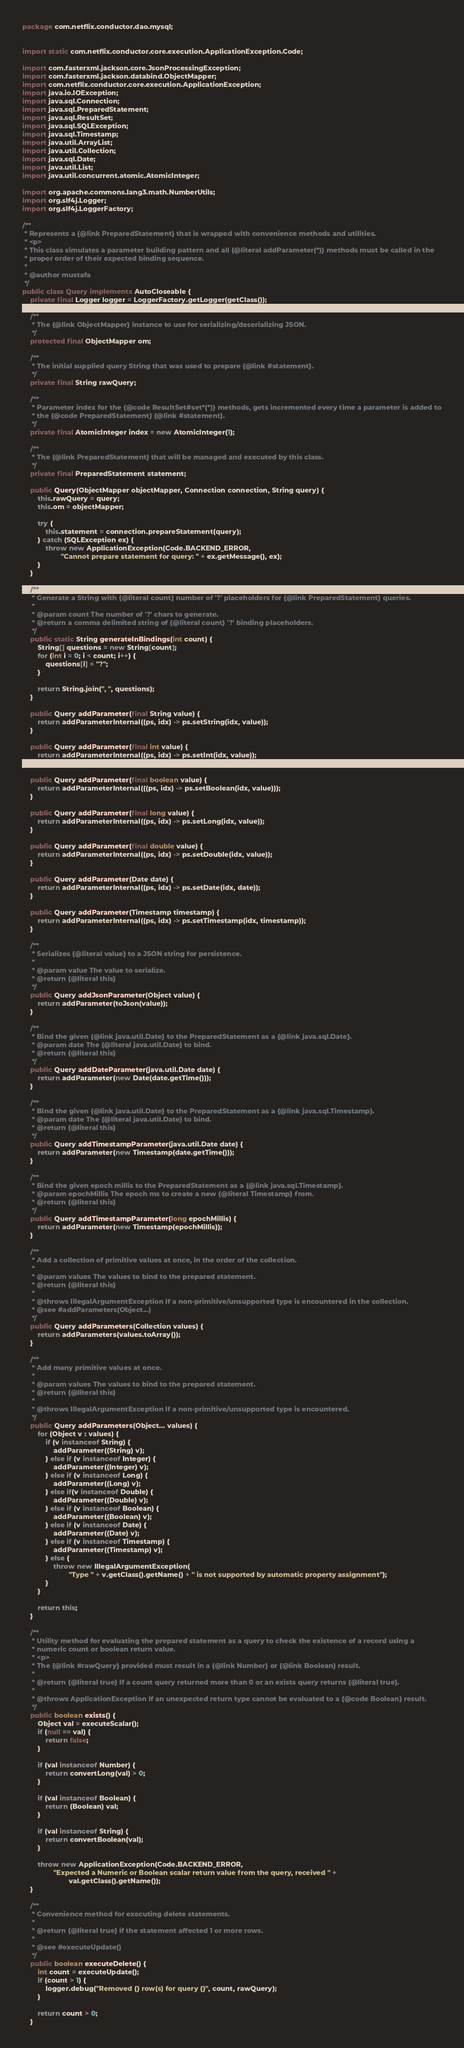<code> <loc_0><loc_0><loc_500><loc_500><_Java_>package com.netflix.conductor.dao.mysql;


import static com.netflix.conductor.core.execution.ApplicationException.Code;

import com.fasterxml.jackson.core.JsonProcessingException;
import com.fasterxml.jackson.databind.ObjectMapper;
import com.netflix.conductor.core.execution.ApplicationException;
import java.io.IOException;
import java.sql.Connection;
import java.sql.PreparedStatement;
import java.sql.ResultSet;
import java.sql.SQLException;
import java.sql.Timestamp;
import java.util.ArrayList;
import java.util.Collection;
import java.sql.Date;
import java.util.List;
import java.util.concurrent.atomic.AtomicInteger;

import org.apache.commons.lang3.math.NumberUtils;
import org.slf4j.Logger;
import org.slf4j.LoggerFactory;

/**
 * Represents a {@link PreparedStatement} that is wrapped with convenience methods and utilities.
 * <p>
 * This class simulates a parameter building pattern and all {@literal addParameter(*)} methods must be called in the
 * proper order of their expected binding sequence.
 *
 * @author mustafa
 */
public class Query implements AutoCloseable {
    private final Logger logger = LoggerFactory.getLogger(getClass());

    /**
     * The {@link ObjectMapper} instance to use for serializing/deserializing JSON.
     */
    protected final ObjectMapper om;

    /**
     * The initial supplied query String that was used to prepare {@link #statement}.
     */
    private final String rawQuery;

    /**
     * Parameter index for the {@code ResultSet#set*(*)} methods, gets incremented every time a parameter is added to
     * the {@code PreparedStatement} {@link #statement}.
     */
    private final AtomicInteger index = new AtomicInteger(1);

    /**
     * The {@link PreparedStatement} that will be managed and executed by this class.
     */
    private final PreparedStatement statement;

    public Query(ObjectMapper objectMapper, Connection connection, String query) {
        this.rawQuery = query;
        this.om = objectMapper;

        try {
            this.statement = connection.prepareStatement(query);
        } catch (SQLException ex) {
            throw new ApplicationException(Code.BACKEND_ERROR,
                    "Cannot prepare statement for query: " + ex.getMessage(), ex);
        }
    }

    /**
     * Generate a String with {@literal count} number of '?' placeholders for {@link PreparedStatement} queries.
     *
     * @param count The number of '?' chars to generate.
     * @return a comma delimited string of {@literal count} '?' binding placeholders.
     */
    public static String generateInBindings(int count) {
        String[] questions = new String[count];
        for (int i = 0; i < count; i++) {
            questions[i] = "?";
        }

        return String.join(", ", questions);
    }

    public Query addParameter(final String value) {
        return addParameterInternal((ps, idx) -> ps.setString(idx, value));
    }

    public Query addParameter(final int value) {
        return addParameterInternal((ps, idx) -> ps.setInt(idx, value));
    }

    public Query addParameter(final boolean value) {
        return addParameterInternal(((ps, idx) -> ps.setBoolean(idx, value)));
    }

    public Query addParameter(final long value) {
        return addParameterInternal((ps, idx) -> ps.setLong(idx, value));
    }

    public Query addParameter(final double value) {
        return addParameterInternal((ps, idx) -> ps.setDouble(idx, value));
    }

    public Query addParameter(Date date) {
        return addParameterInternal((ps, idx) -> ps.setDate(idx, date));
    }

    public Query addParameter(Timestamp timestamp) {
        return addParameterInternal((ps, idx) -> ps.setTimestamp(idx, timestamp));
    }

    /**
     * Serializes {@literal value} to a JSON string for persistence.
     *
     * @param value The value to serialize.
     * @return {@literal this}
     */
    public Query addJsonParameter(Object value) {
        return addParameter(toJson(value));
    }

    /**
     * Bind the given {@link java.util.Date} to the PreparedStatement as a {@link java.sql.Date}.
     * @param date The {@literal java.util.Date} to bind.
     * @return {@literal this}
     */
    public Query addDateParameter(java.util.Date date) {
        return addParameter(new Date(date.getTime()));
    }

    /**
     * Bind the given {@link java.util.Date} to the PreparedStatement as a {@link java.sql.Timestamp}.
     * @param date The {@literal java.util.Date} to bind.
     * @return {@literal this}
     */
    public Query addTimestampParameter(java.util.Date date) {
        return addParameter(new Timestamp(date.getTime()));
    }

    /**
     * Bind the given epoch millis to the PreparedStatement as a {@link java.sql.Timestamp}.
     * @param epochMillis The epoch ms to create a new {@literal Timestamp} from.
     * @return {@literal this}
     */
    public Query addTimestampParameter(long epochMillis) {
        return addParameter(new Timestamp(epochMillis));
    }

    /**
     * Add a collection of primitive values at once, in the order of the collection.
     *
     * @param values The values to bind to the prepared statement.
     * @return {@literal this}
     *
     * @throws IllegalArgumentException If a non-primitive/unsupported type is encountered in the collection.
     * @see #addParameters(Object...)
     */
    public Query addParameters(Collection values) {
        return addParameters(values.toArray());
    }

    /**
     * Add many primitive values at once.
     *
     * @param values The values to bind to the prepared statement.
     * @return {@literal this}
     *
     * @throws IllegalArgumentException If a non-primitive/unsupported type is encountered.
     */
    public Query addParameters(Object... values) {
        for (Object v : values) {
            if (v instanceof String) {
                addParameter((String) v);
            } else if (v instanceof Integer) {
                addParameter((Integer) v);
            } else if (v instanceof Long) {
                addParameter((Long) v);
            } else if(v instanceof Double) {
                addParameter((Double) v);
            } else if (v instanceof Boolean) {
                addParameter((Boolean) v);
            } else if (v instanceof Date) {
                addParameter((Date) v);
            } else if (v instanceof Timestamp) {
                addParameter((Timestamp) v);
            } else {
                throw new IllegalArgumentException(
                        "Type " + v.getClass().getName() + " is not supported by automatic property assignment");
            }
        }

        return this;
    }

    /**
     * Utility method for evaluating the prepared statement as a query to check the existence of a record using a
     * numeric count or boolean return value.
     * <p>
     * The {@link #rawQuery} provided must result in a {@link Number} or {@link Boolean} result.
     *
     * @return {@literal true} If a count query returned more than 0 or an exists query returns {@literal true}.
     *
     * @throws ApplicationException If an unexpected return type cannot be evaluated to a {@code Boolean} result.
     */
    public boolean exists() {
        Object val = executeScalar();
        if (null == val) {
            return false;
        }

        if (val instanceof Number) {
            return convertLong(val) > 0;
        }

        if (val instanceof Boolean) {
            return (Boolean) val;
        }

        if (val instanceof String) {
            return convertBoolean(val);
        }

        throw new ApplicationException(Code.BACKEND_ERROR,
                "Expected a Numeric or Boolean scalar return value from the query, received " +
                        val.getClass().getName());
    }

    /**
     * Convenience method for executing delete statements.
     *
     * @return {@literal true} if the statement affected 1 or more rows.
     *
     * @see #executeUpdate()
     */
    public boolean executeDelete() {
        int count = executeUpdate();
        if (count > 1) {
            logger.debug("Removed {} row(s) for query {}", count, rawQuery);
        }

        return count > 0;
    }
</code> 